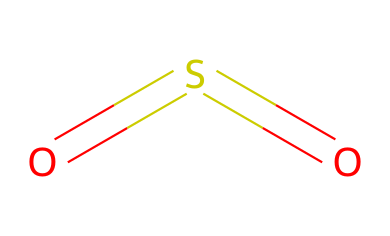What is the name of this chemical? The SMILES representation "O=S=O" indicates a molecule composed of one sulfur atom bonded to two oxygen atoms in a linear arrangement. This structure corresponds to sulfur dioxide, which is a known chemical compound.
Answer: sulfur dioxide How many oxygen atoms are present in this compound? By analyzing the SMILES representation "O=S=O," it can be seen that there are two oxygen atoms attached to the sulfur atom.
Answer: two What type of bonds are present in sulfur dioxide? In the given structure "O=S=O," the bond between sulfur and each oxygen is a double bond, represented by the equals sign (=). Therefore, this compound contains two double bonds.
Answer: double bonds Is sulfur dioxide considered an air pollutant? Yes, sulfur dioxide is known to be an air pollutant due to its release from industrial processes and its contribution to acid rain, which negatively impacts air quality and respiratory health.
Answer: yes What impact does sulfur dioxide have on athletes’ respiratory performance? Sulfur dioxide can cause airway inflammation and bronchoconstriction, which can lead to respiratory difficulties during exercise, particularly in endurance athletes.
Answer: respiratory difficulties How many total atoms are in sulfur dioxide? The structure represented in the SMILES notation "O=S=O" shows that there is one sulfur atom and two oxygen atoms, thus totaling three atoms in the molecule.
Answer: three 